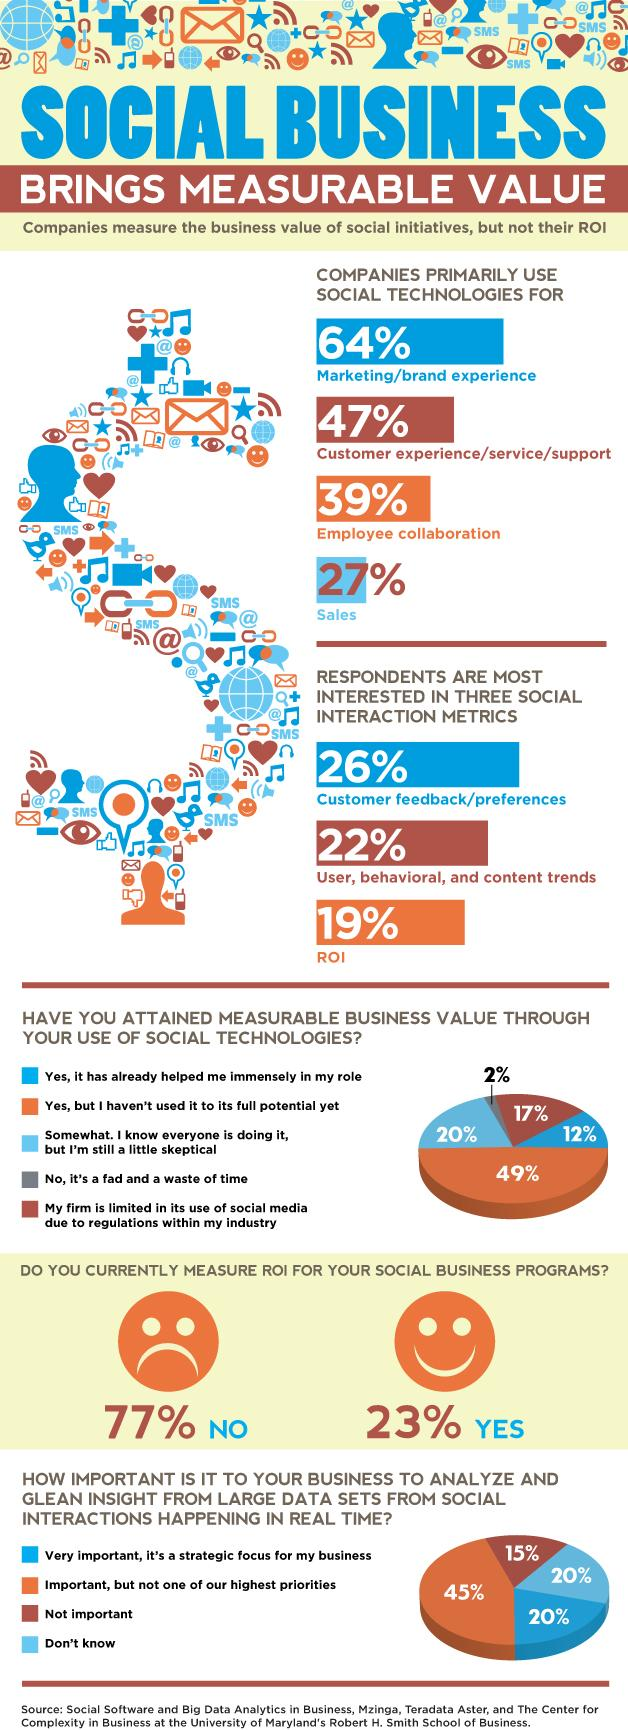Indicate a few pertinent items in this graphic. According to the survey results, the respondents were least interested in the social interaction metric of return on investment (ROI). According to the survey, only 2% of respondents believe that social technology is a fad and a waste of time. According to a recent survey, 47% of companies primarily use social technologies for customer service. According to the survey, only 12% of respondents believe that social technologies have greatly assisted them in their role. Approximately 17% of businesses have restricted the use of social media due to industry regulations. 